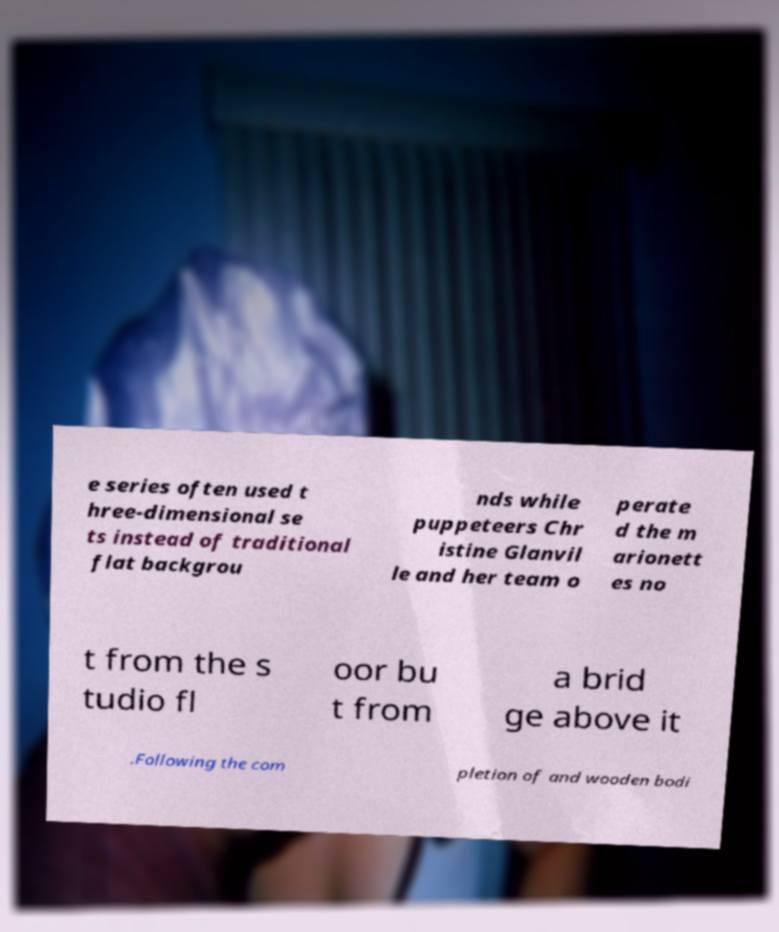I need the written content from this picture converted into text. Can you do that? e series often used t hree-dimensional se ts instead of traditional flat backgrou nds while puppeteers Chr istine Glanvil le and her team o perate d the m arionett es no t from the s tudio fl oor bu t from a brid ge above it .Following the com pletion of and wooden bodi 